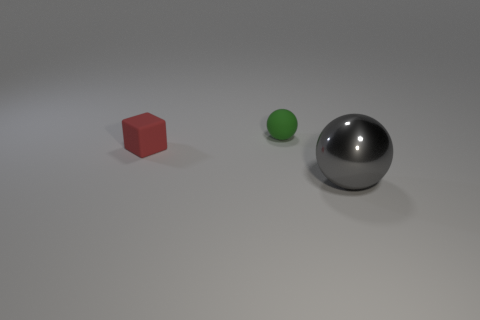Are there any other things that have the same size as the metallic ball?
Offer a very short reply. No. Is there anything else that has the same material as the large gray object?
Make the answer very short. No. Does the ball behind the red object have the same material as the thing in front of the tiny red cube?
Your response must be concise. No. What is the tiny green object made of?
Your answer should be compact. Rubber. What number of yellow objects are the same shape as the tiny green rubber thing?
Offer a terse response. 0. Is there any other thing that is the same shape as the large gray shiny object?
Offer a very short reply. Yes. The tiny rubber object that is on the right side of the small rubber thing in front of the small thing behind the small red rubber block is what color?
Provide a succinct answer. Green. How many tiny things are either matte blocks or green objects?
Offer a very short reply. 2. Are there an equal number of metal balls behind the big metallic object and small green rubber spheres?
Give a very brief answer. No. Are there any small red matte cubes in front of the gray object?
Give a very brief answer. No. 